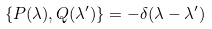<formula> <loc_0><loc_0><loc_500><loc_500>\{ P ( \lambda ) , Q ( \lambda ^ { \prime } ) \} = - \delta ( \lambda - \lambda ^ { \prime } )</formula> 